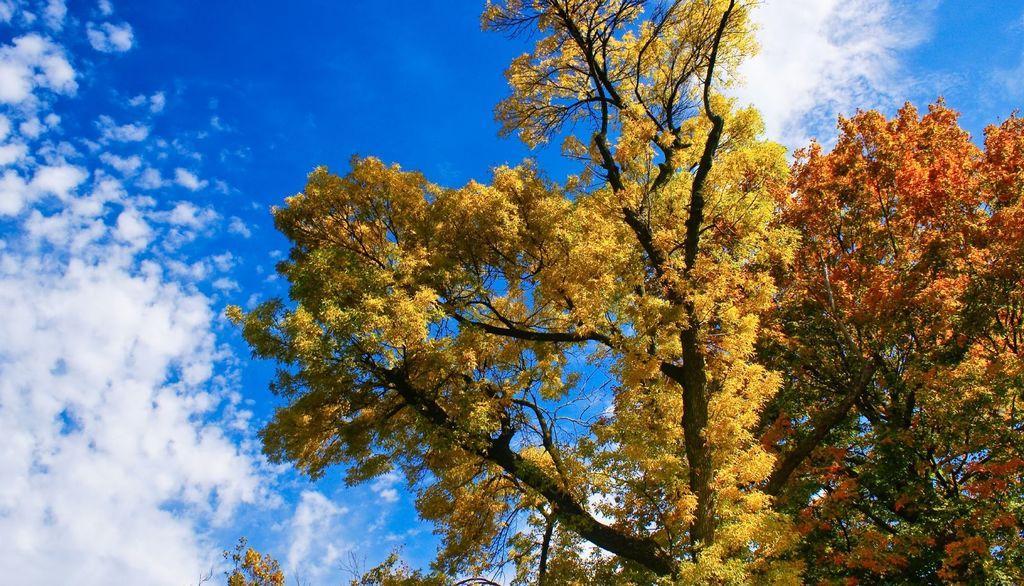Please provide a concise description of this image. On the right side there are trees with yellow leaves and red leaves. In the background there is sky with clouds. 